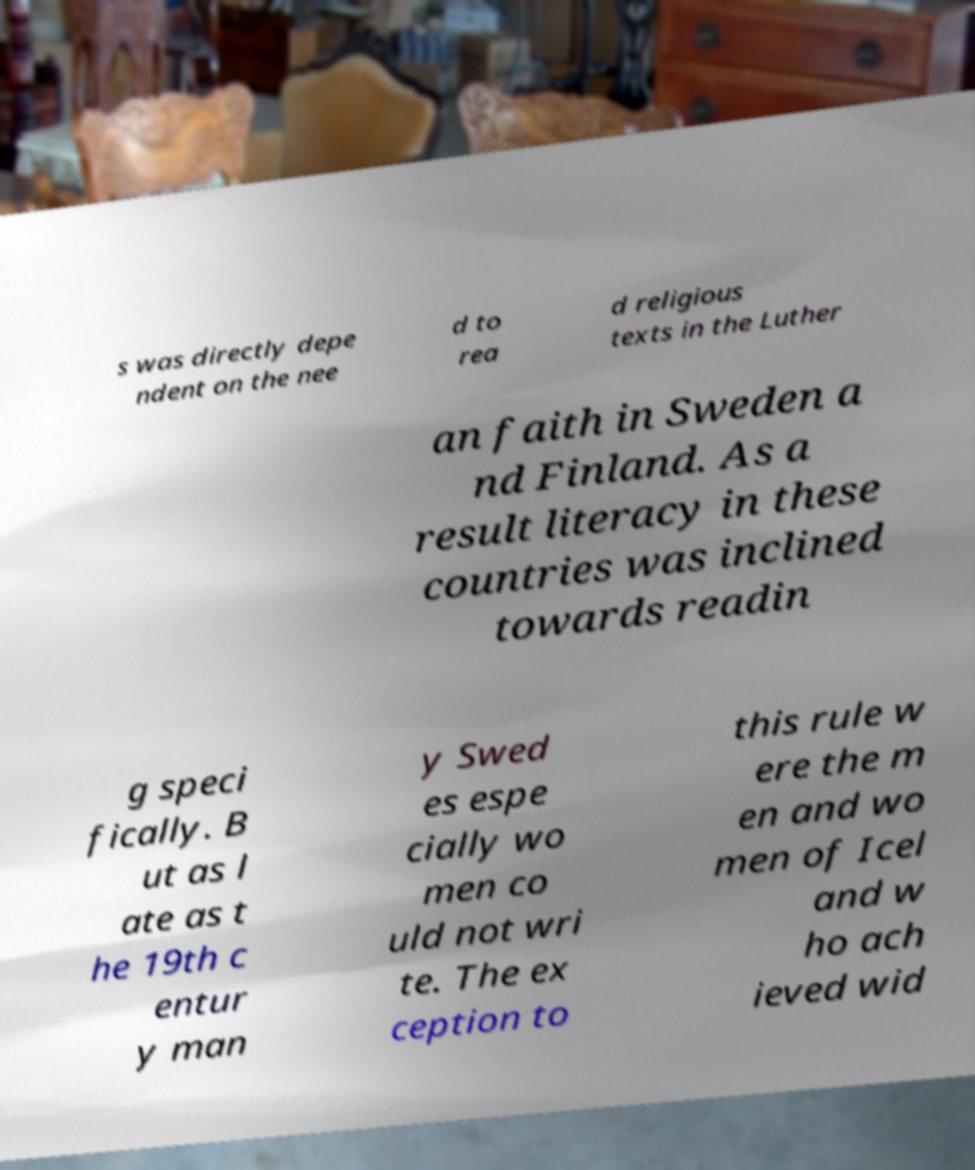For documentation purposes, I need the text within this image transcribed. Could you provide that? s was directly depe ndent on the nee d to rea d religious texts in the Luther an faith in Sweden a nd Finland. As a result literacy in these countries was inclined towards readin g speci fically. B ut as l ate as t he 19th c entur y man y Swed es espe cially wo men co uld not wri te. The ex ception to this rule w ere the m en and wo men of Icel and w ho ach ieved wid 